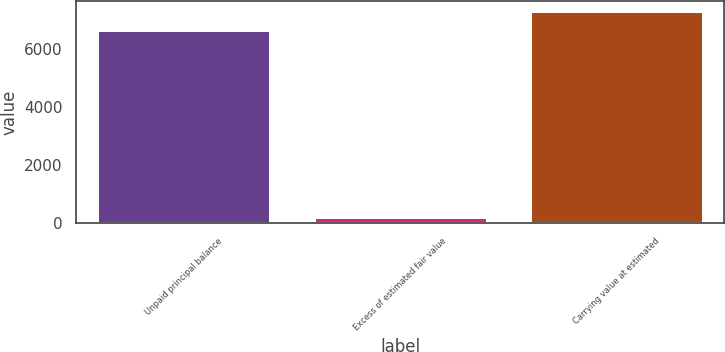<chart> <loc_0><loc_0><loc_500><loc_500><bar_chart><fcel>Unpaid principal balance<fcel>Excess of estimated fair value<fcel>Carrying value at estimated<nl><fcel>6636<fcel>204<fcel>7299.6<nl></chart> 